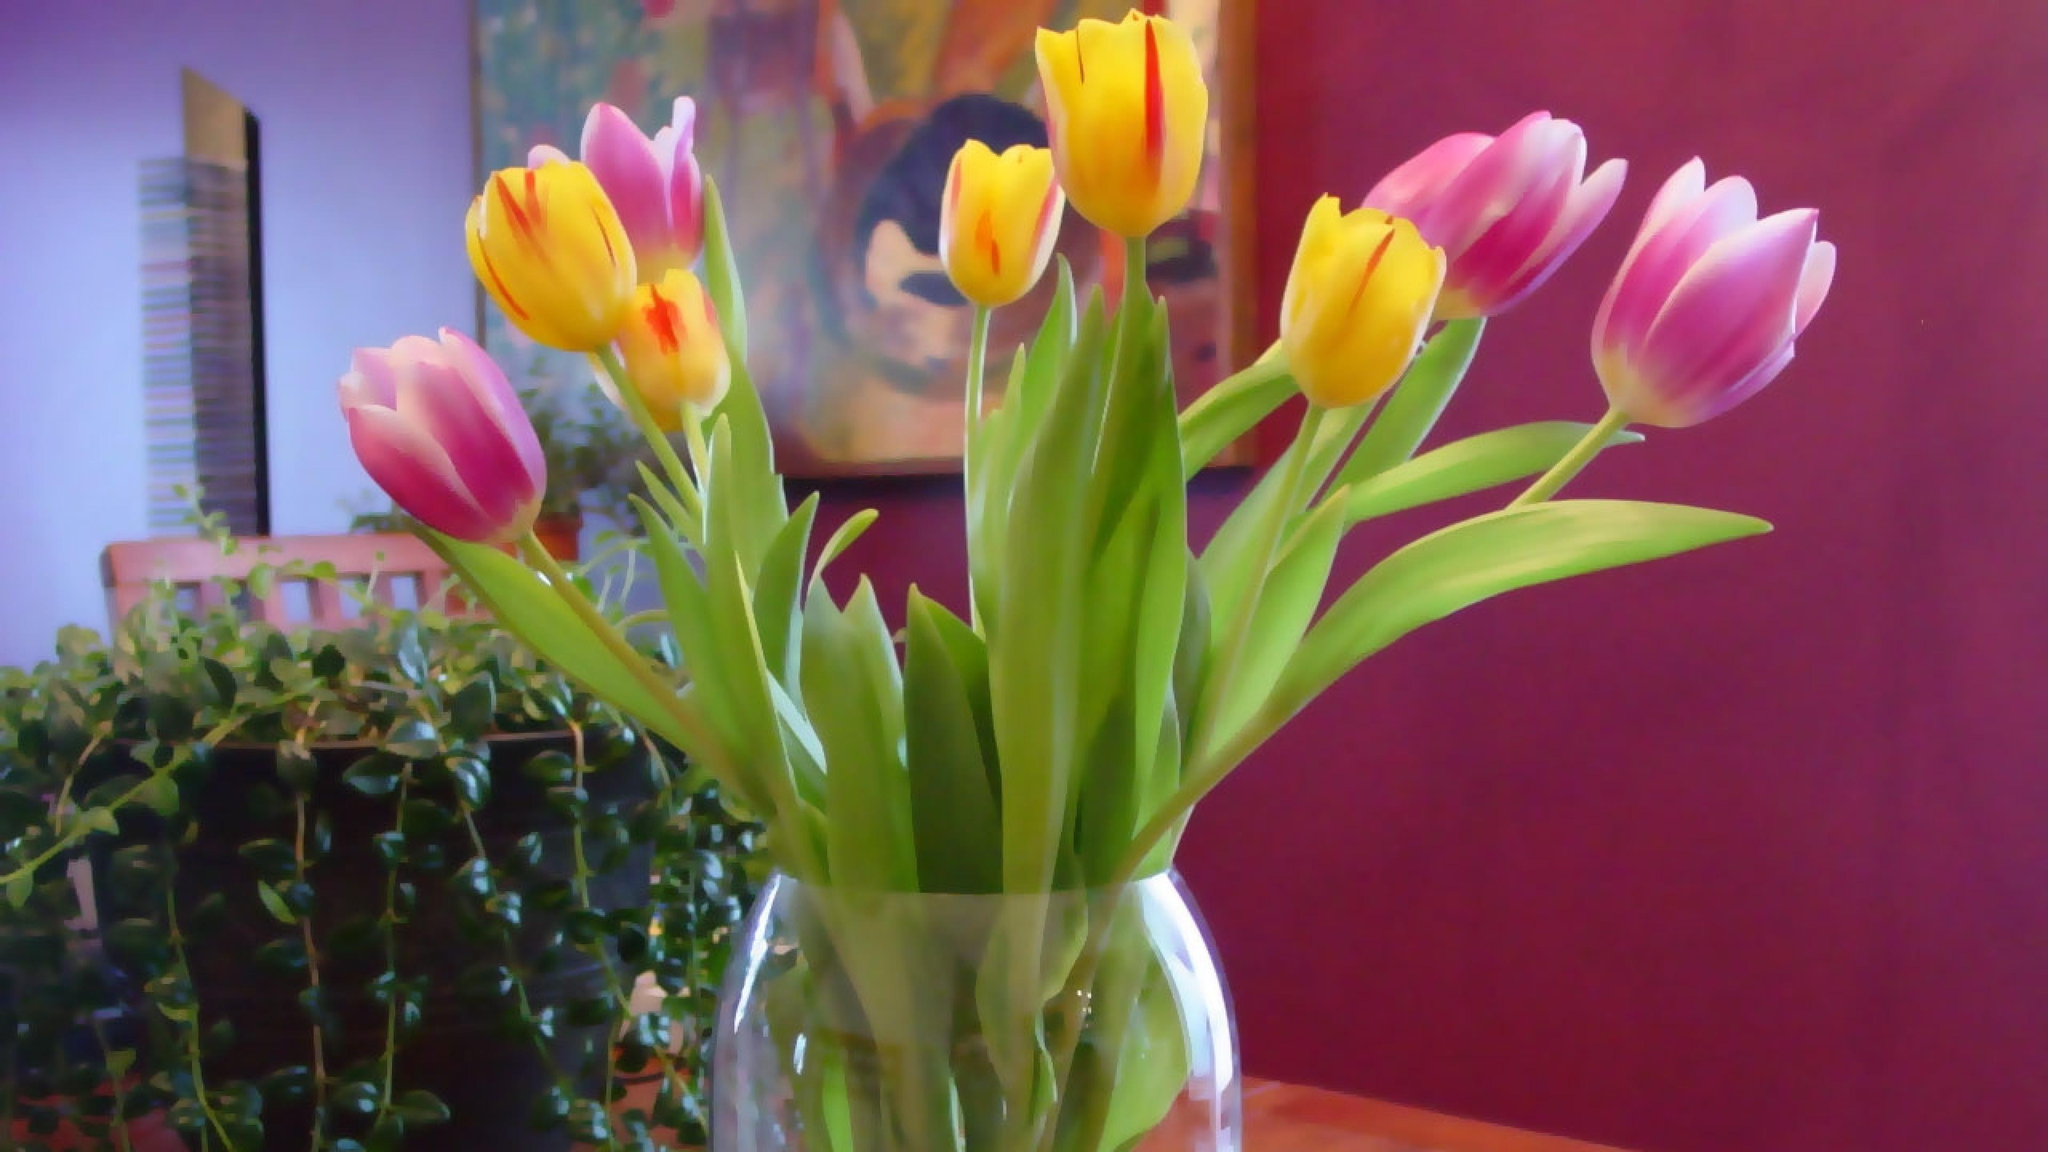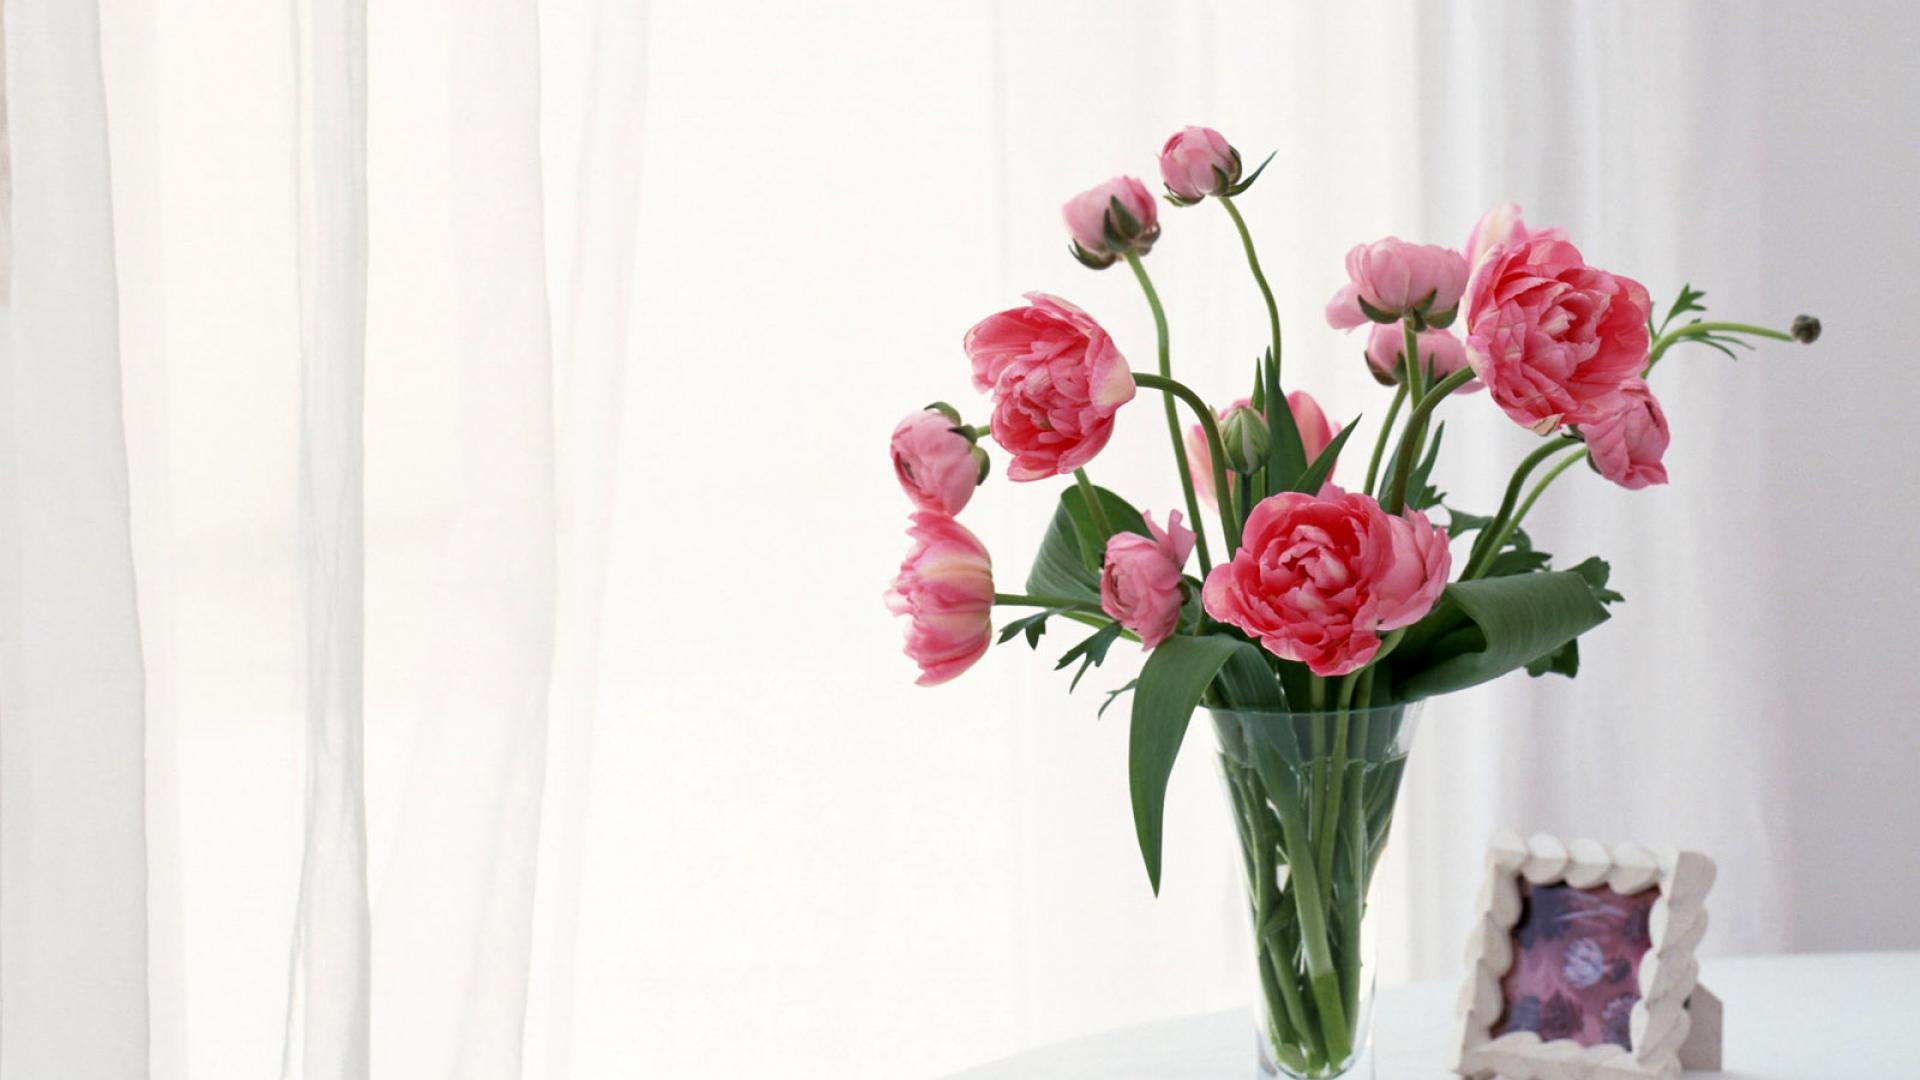The first image is the image on the left, the second image is the image on the right. Considering the images on both sides, is "There are books with the flowers." valid? Answer yes or no. No. The first image is the image on the left, the second image is the image on the right. Assess this claim about the two images: "Each image contains exactly one vase of flowers, and the vase in one image contains multiple flower colors, while the other contains flowers with a single petal color.". Correct or not? Answer yes or no. Yes. 